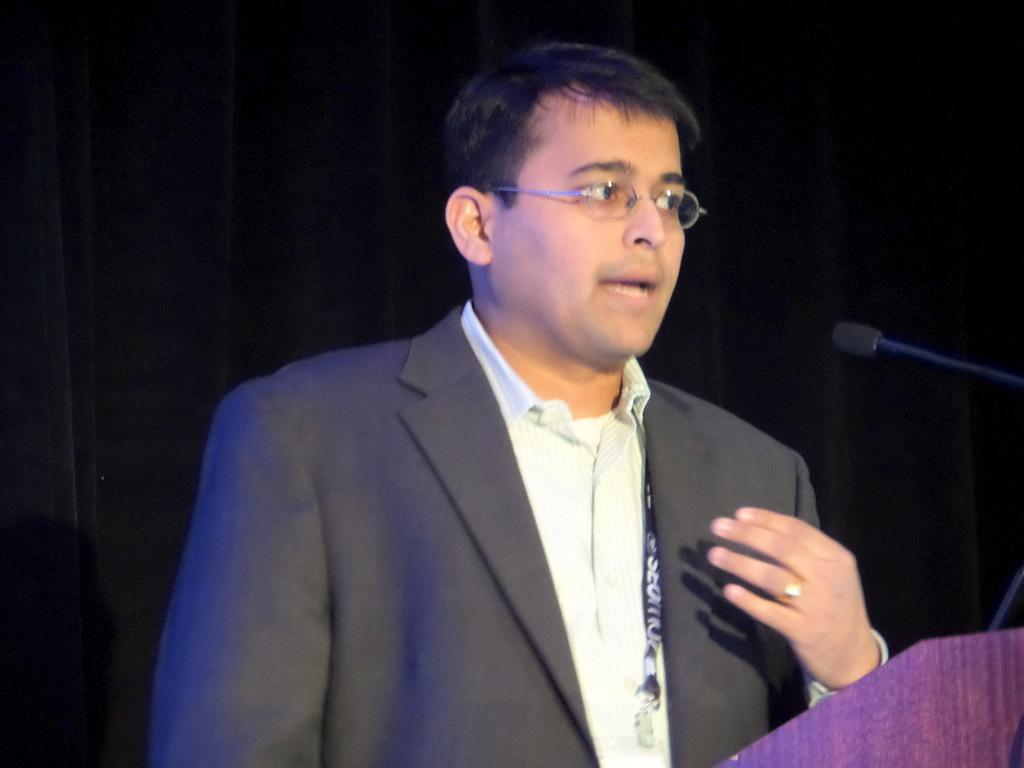Who is the main subject in the image? There is a man in the image. What is the man doing in the image? The man is standing in front of a microphone and talking. What can be seen behind the man in the image? There is a black curtain at the back side of the image. What type of alley can be seen behind the man in the image? There is no alley present in the image; it features a black curtain at the back side. 